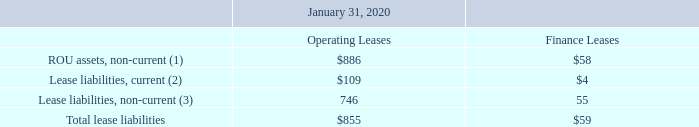Supplemental balance sheet information related to operating and finance leases as of the period presented was as follows (table in millions):
(1) ROU assets for operating leases are included in other assets and ROU assets for finance leases are included in property and equipment, net on the consolidated balance sheets
(2) Current lease liabilities are included primarily in accrued expenses and other on the consolidated balance sheets. An immaterial amount is presented in due from related parties, net on the consolidated balance sheets.
(3) Operating lease liabilities are presented as operating lease liabilities on the consolidated balance sheets. Finance lease liabilities are included in other liabilities on the consolidated balance sheets.
What were the current lease liabilities for operating leases?
Answer scale should be: million. 109. What were the total lease liabilities for finance leases?
Answer scale should be: million. 59. Where are ROU assets for operating leases included in the consolidated balance sheets? Rou assets for operating leases are included in other assets and rou assets for finance leases are included in property and equipment, net. How many lease liabilities for operating leases exceeded $500 million? Lease liabilities, non-current
Answer: 1. What was the difference between current and non-current lease liabilities for operating leases?
Answer scale should be: million. 746-109
Answer: 637. What was the difference in total lease liabilities between operating leases and finance leases?
Answer scale should be: million. 855-59
Answer: 796. 